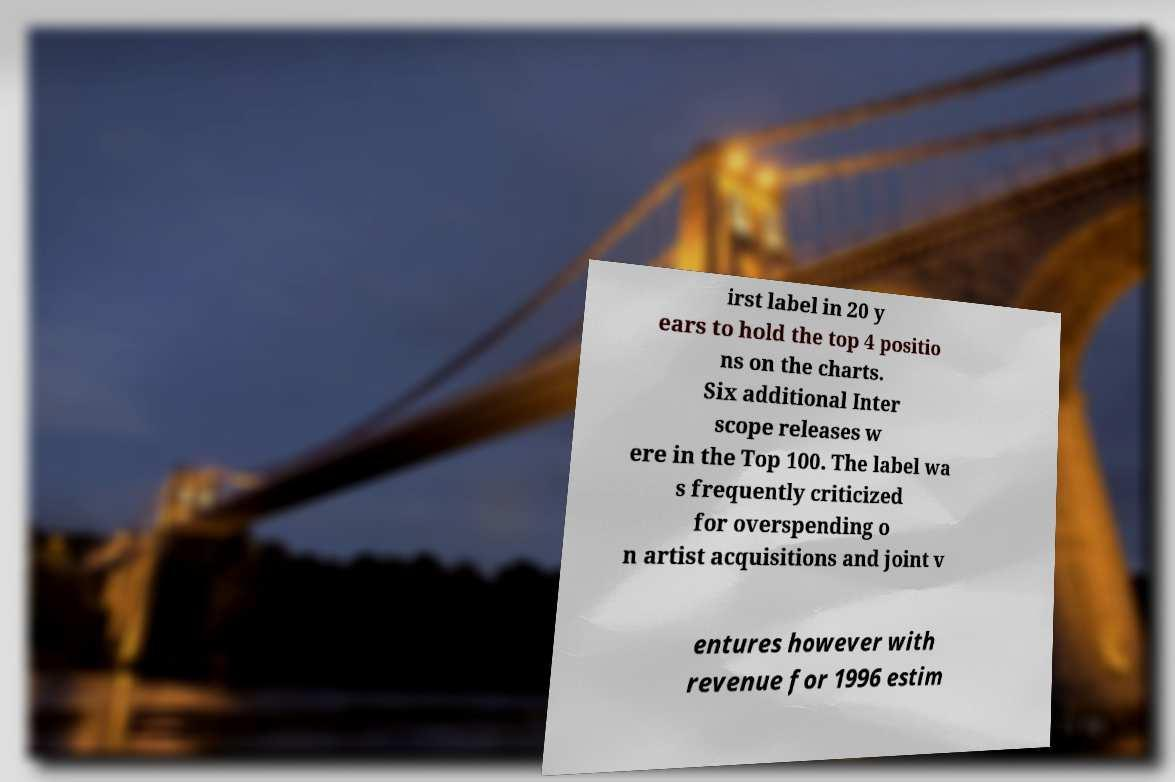For documentation purposes, I need the text within this image transcribed. Could you provide that? irst label in 20 y ears to hold the top 4 positio ns on the charts. Six additional Inter scope releases w ere in the Top 100. The label wa s frequently criticized for overspending o n artist acquisitions and joint v entures however with revenue for 1996 estim 